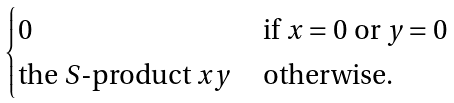Convert formula to latex. <formula><loc_0><loc_0><loc_500><loc_500>\begin{cases} 0 & \text { if } x = 0 \text { or } y = 0 \\ \text {the $S$-product } x y & \text { otherwise} . \end{cases}</formula> 